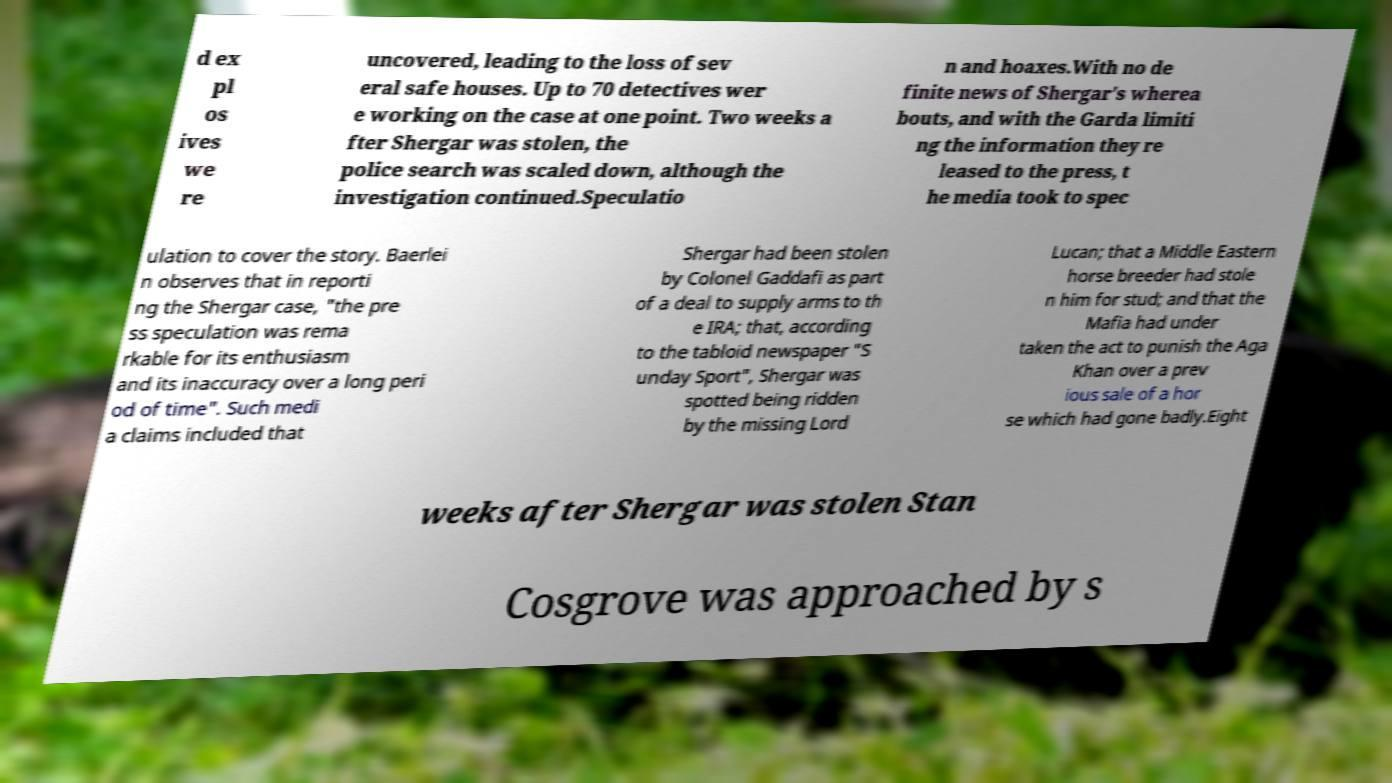Please identify and transcribe the text found in this image. d ex pl os ives we re uncovered, leading to the loss of sev eral safe houses. Up to 70 detectives wer e working on the case at one point. Two weeks a fter Shergar was stolen, the police search was scaled down, although the investigation continued.Speculatio n and hoaxes.With no de finite news of Shergar's wherea bouts, and with the Garda limiti ng the information they re leased to the press, t he media took to spec ulation to cover the story. Baerlei n observes that in reporti ng the Shergar case, "the pre ss speculation was rema rkable for its enthusiasm and its inaccuracy over a long peri od of time". Such medi a claims included that Shergar had been stolen by Colonel Gaddafi as part of a deal to supply arms to th e IRA; that, according to the tabloid newspaper "S unday Sport", Shergar was spotted being ridden by the missing Lord Lucan; that a Middle Eastern horse breeder had stole n him for stud; and that the Mafia had under taken the act to punish the Aga Khan over a prev ious sale of a hor se which had gone badly.Eight weeks after Shergar was stolen Stan Cosgrove was approached by s 